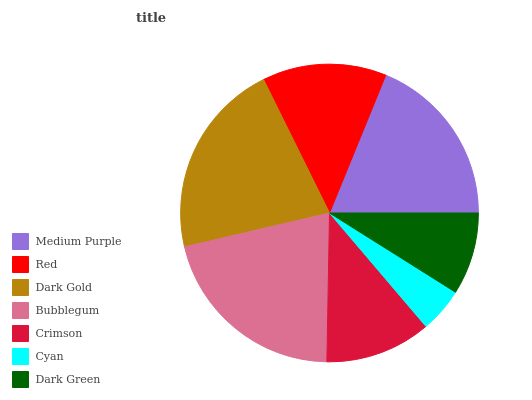Is Cyan the minimum?
Answer yes or no. Yes. Is Dark Gold the maximum?
Answer yes or no. Yes. Is Red the minimum?
Answer yes or no. No. Is Red the maximum?
Answer yes or no. No. Is Medium Purple greater than Red?
Answer yes or no. Yes. Is Red less than Medium Purple?
Answer yes or no. Yes. Is Red greater than Medium Purple?
Answer yes or no. No. Is Medium Purple less than Red?
Answer yes or no. No. Is Red the high median?
Answer yes or no. Yes. Is Red the low median?
Answer yes or no. Yes. Is Crimson the high median?
Answer yes or no. No. Is Crimson the low median?
Answer yes or no. No. 